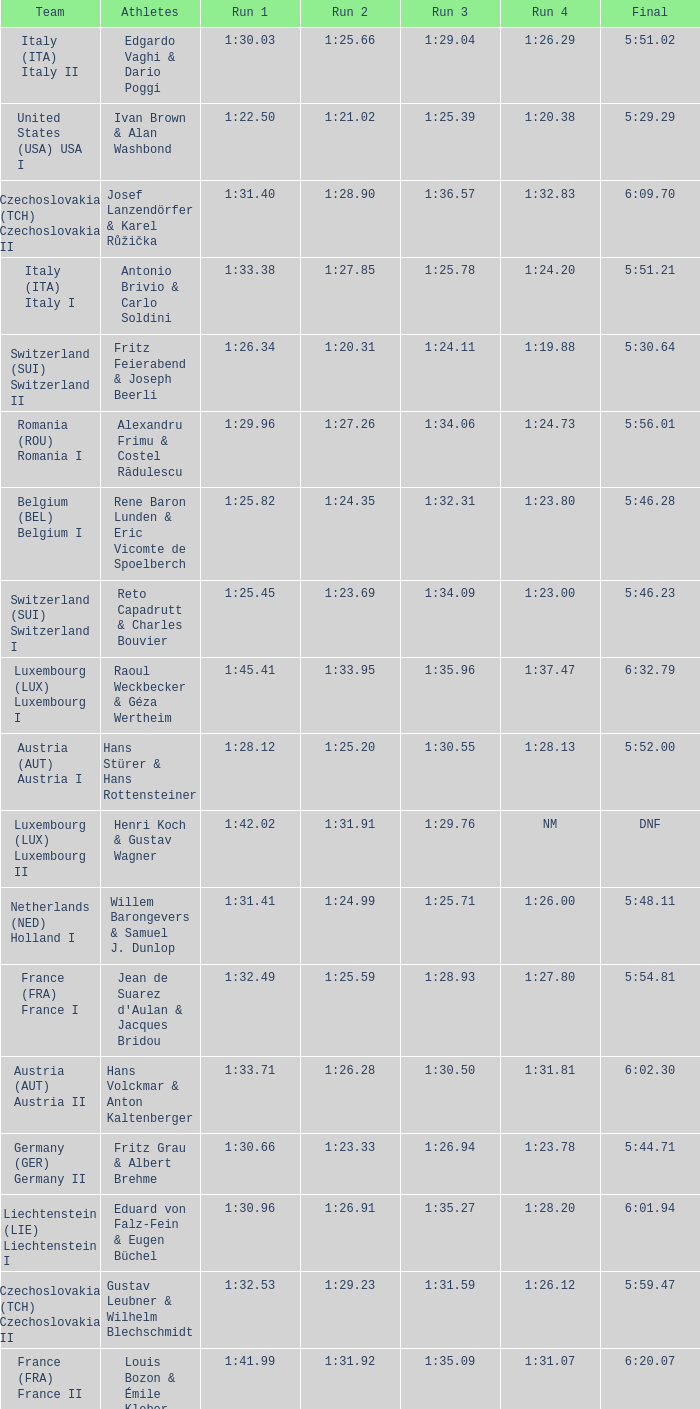Which Final has a Run 2 of 1:27.58? 5:58.91. 